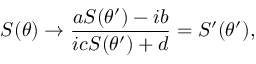Convert formula to latex. <formula><loc_0><loc_0><loc_500><loc_500>S ( \theta ) \rightarrow \frac { a S ( \theta ^ { \prime } ) - i b } { i c S ( \theta ^ { \prime } ) + d } = S ^ { \prime } ( \theta ^ { \prime } ) ,</formula> 